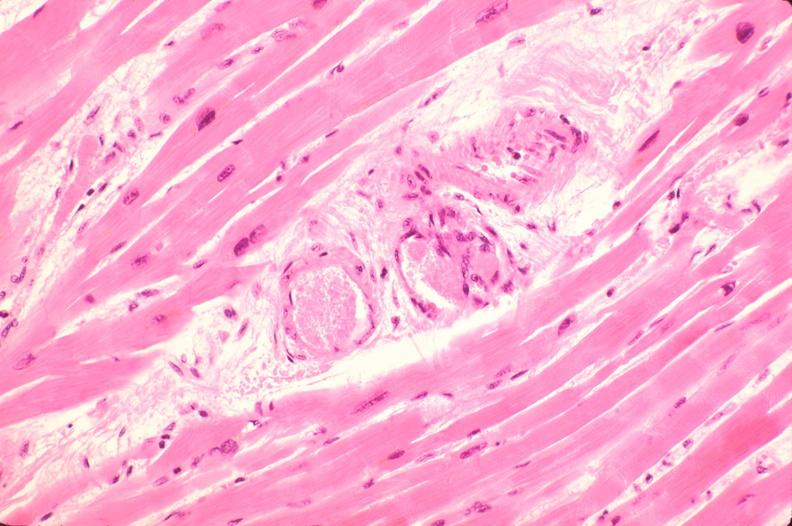does this image show heart, microthrombi, thrombotic thrombocytopenic purpura?
Answer the question using a single word or phrase. Yes 